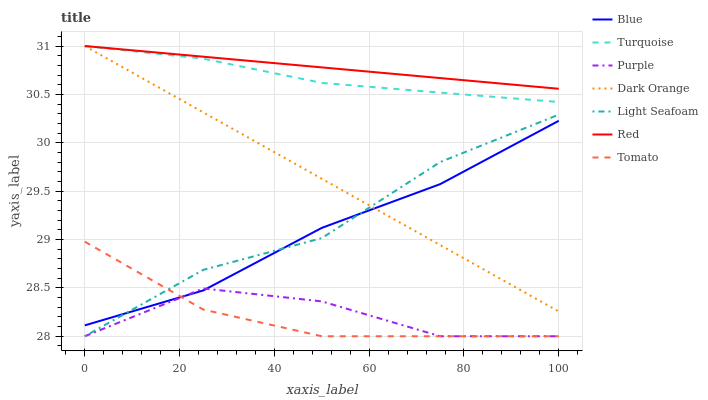Does Tomato have the minimum area under the curve?
Answer yes or no. Yes. Does Red have the maximum area under the curve?
Answer yes or no. Yes. Does Dark Orange have the minimum area under the curve?
Answer yes or no. No. Does Dark Orange have the maximum area under the curve?
Answer yes or no. No. Is Red the smoothest?
Answer yes or no. Yes. Is Purple the roughest?
Answer yes or no. Yes. Is Dark Orange the smoothest?
Answer yes or no. No. Is Dark Orange the roughest?
Answer yes or no. No. Does Purple have the lowest value?
Answer yes or no. Yes. Does Dark Orange have the lowest value?
Answer yes or no. No. Does Red have the highest value?
Answer yes or no. Yes. Does Purple have the highest value?
Answer yes or no. No. Is Blue less than Turquoise?
Answer yes or no. Yes. Is Dark Orange greater than Purple?
Answer yes or no. Yes. Does Dark Orange intersect Red?
Answer yes or no. Yes. Is Dark Orange less than Red?
Answer yes or no. No. Is Dark Orange greater than Red?
Answer yes or no. No. Does Blue intersect Turquoise?
Answer yes or no. No. 